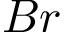<formula> <loc_0><loc_0><loc_500><loc_500>B r</formula> 